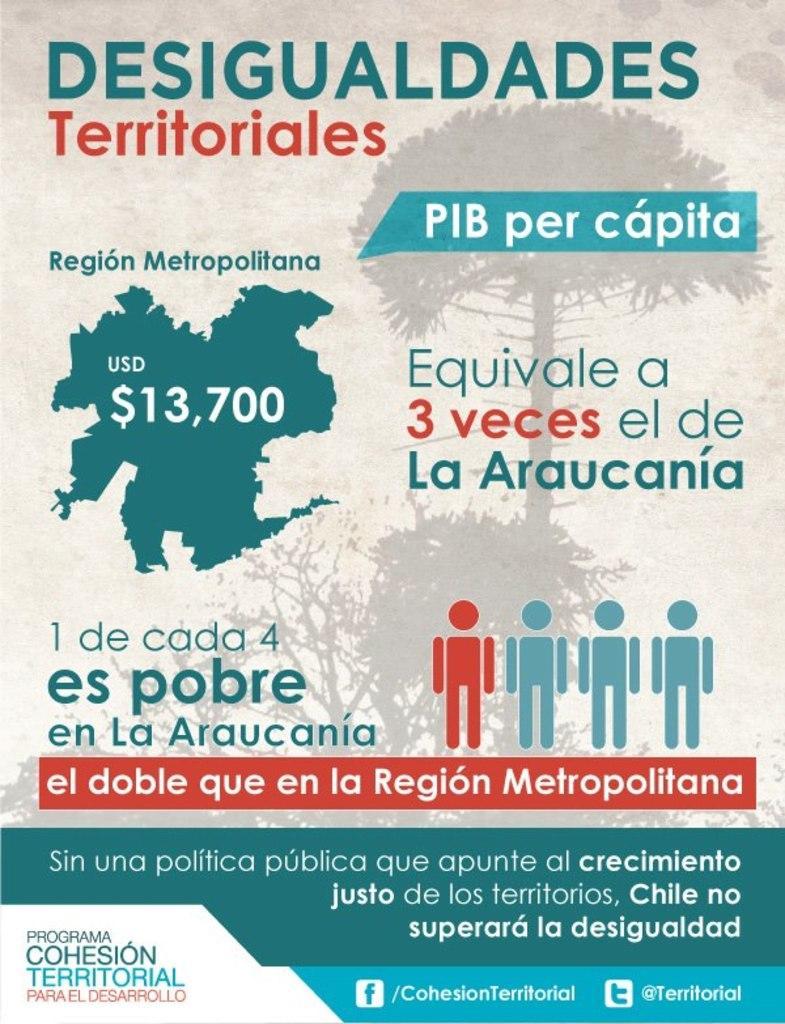In one or two sentences, can you explain what this image depicts? In this image, we can see a magazine. In this magazine, we can see some text, image, numerical numbers, figures. 